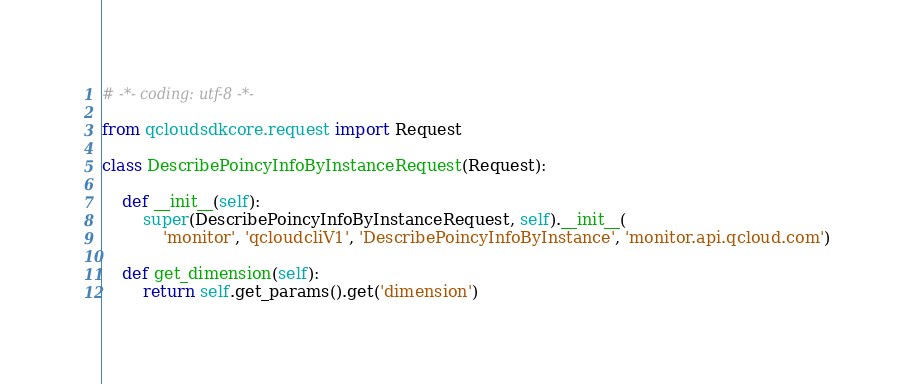<code> <loc_0><loc_0><loc_500><loc_500><_Python_># -*- coding: utf-8 -*-

from qcloudsdkcore.request import Request

class DescribePoincyInfoByInstanceRequest(Request):

    def __init__(self):
        super(DescribePoincyInfoByInstanceRequest, self).__init__(
            'monitor', 'qcloudcliV1', 'DescribePoincyInfoByInstance', 'monitor.api.qcloud.com')

    def get_dimension(self):
        return self.get_params().get('dimension')
</code> 